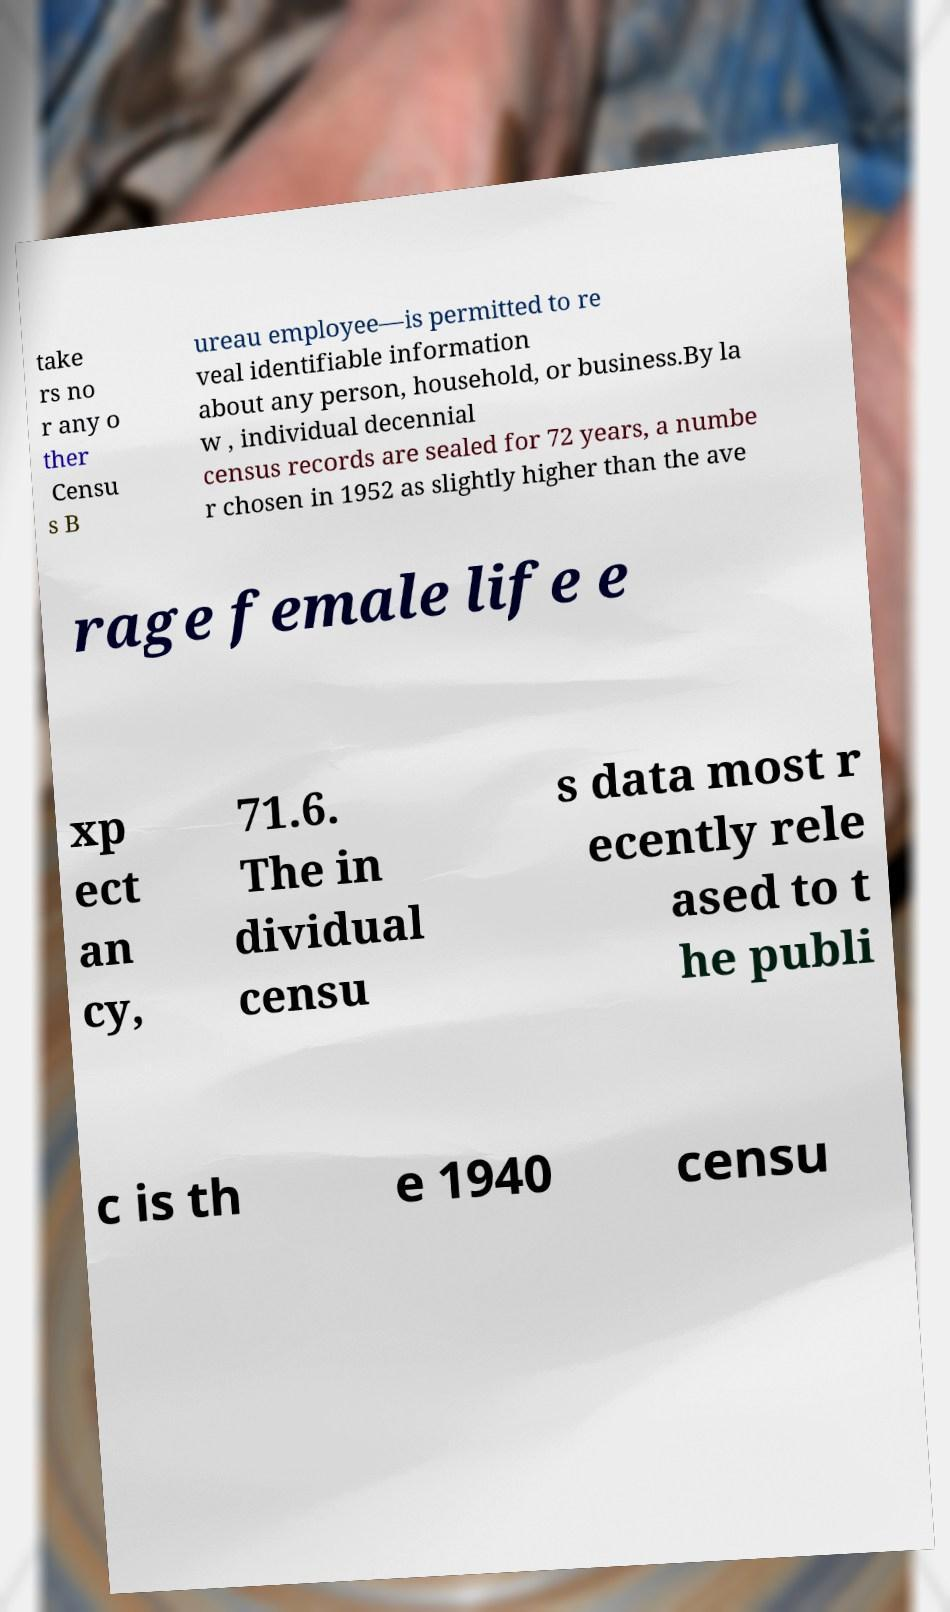I need the written content from this picture converted into text. Can you do that? take rs no r any o ther Censu s B ureau employee—is permitted to re veal identifiable information about any person, household, or business.By la w , individual decennial census records are sealed for 72 years, a numbe r chosen in 1952 as slightly higher than the ave rage female life e xp ect an cy, 71.6. The in dividual censu s data most r ecently rele ased to t he publi c is th e 1940 censu 